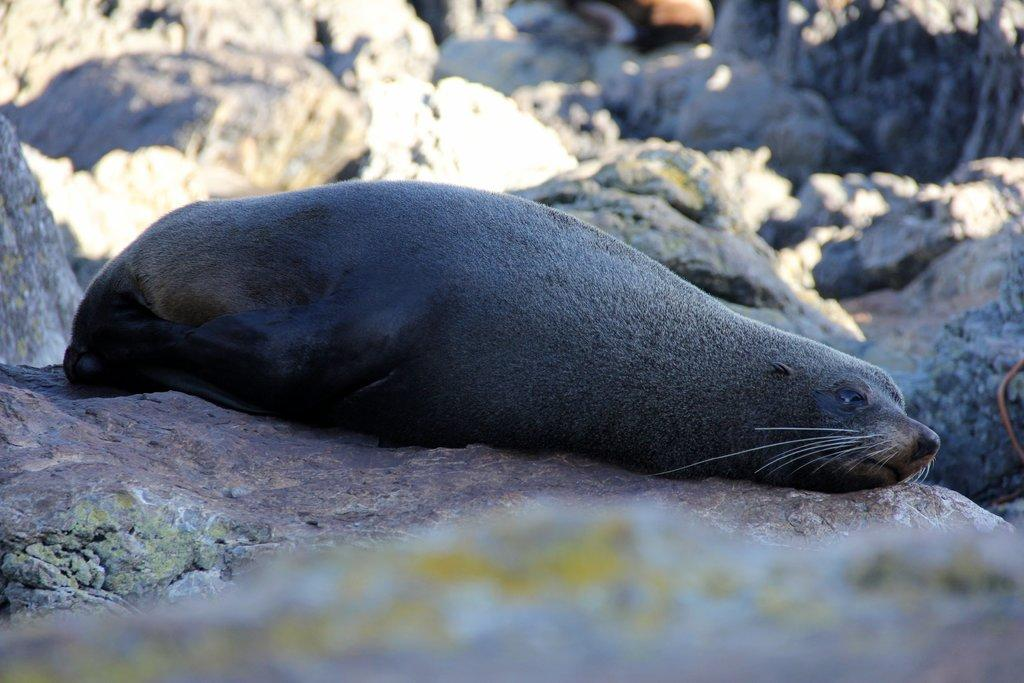What is the main subject in the center of the image? There is a seal in the center of the image. What is the color of the seal? The seal is black in color. What is the seal resting on? The seal is on a stone. What can be seen in the background of the image? There are stones visible in the background of the image. Where is the basket located in the image? There is no basket present in the image. What type of plastic object can be seen in the image? There is no plastic object present in the image. 